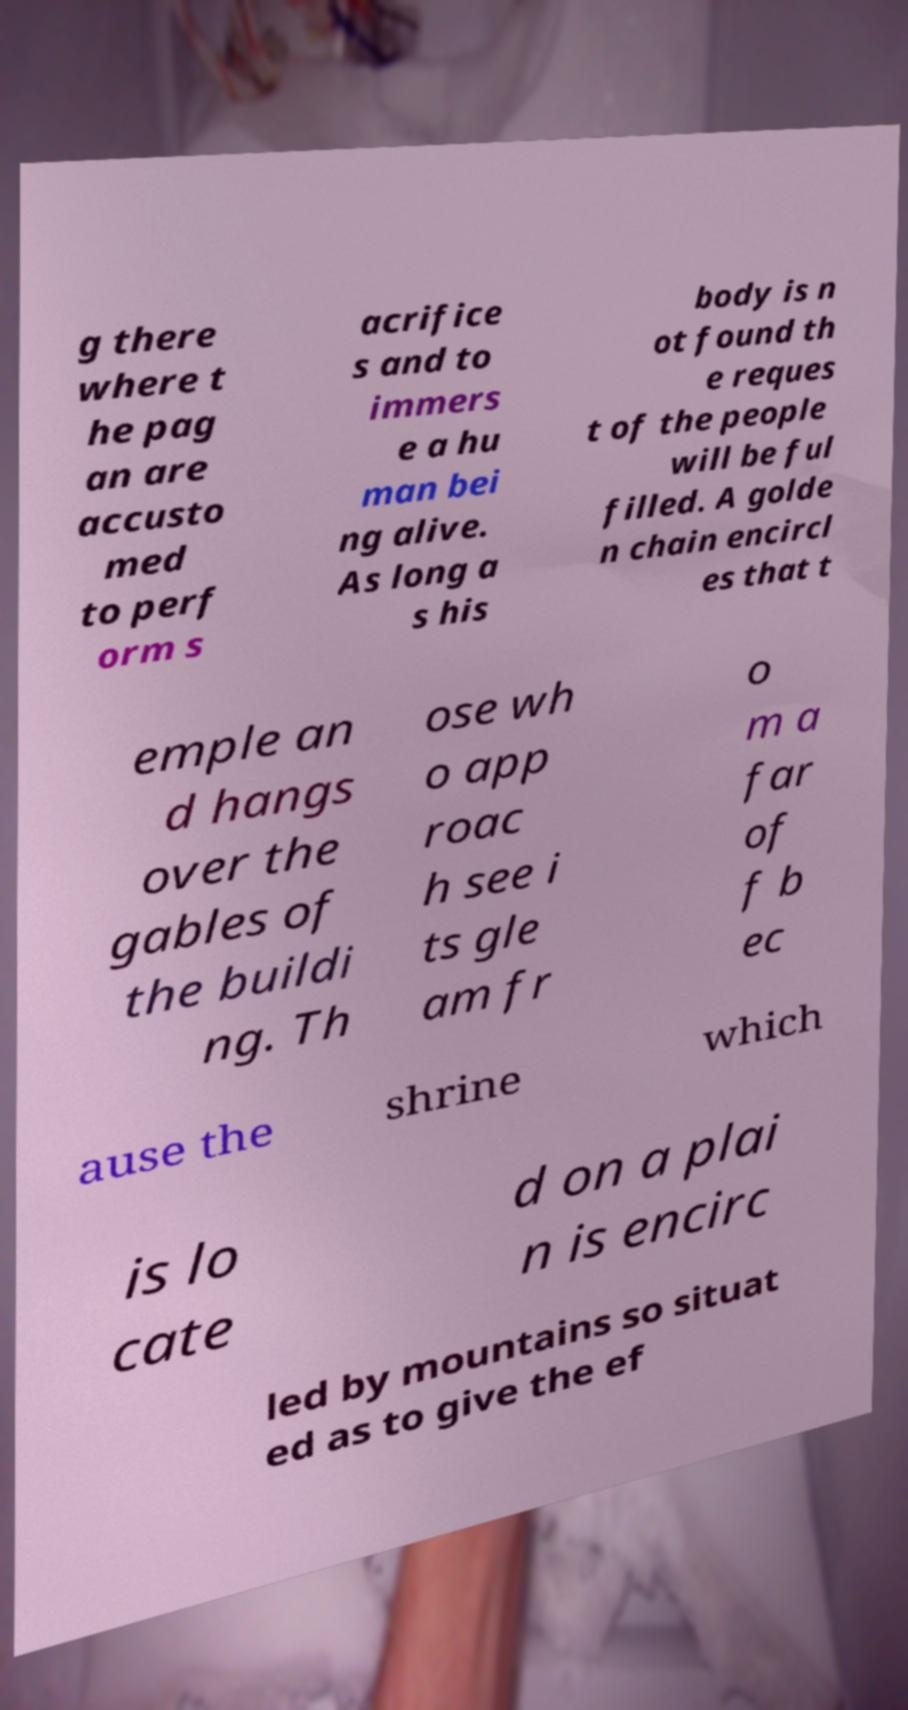Can you read and provide the text displayed in the image?This photo seems to have some interesting text. Can you extract and type it out for me? g there where t he pag an are accusto med to perf orm s acrifice s and to immers e a hu man bei ng alive. As long a s his body is n ot found th e reques t of the people will be ful filled. A golde n chain encircl es that t emple an d hangs over the gables of the buildi ng. Th ose wh o app roac h see i ts gle am fr o m a far of f b ec ause the shrine which is lo cate d on a plai n is encirc led by mountains so situat ed as to give the ef 